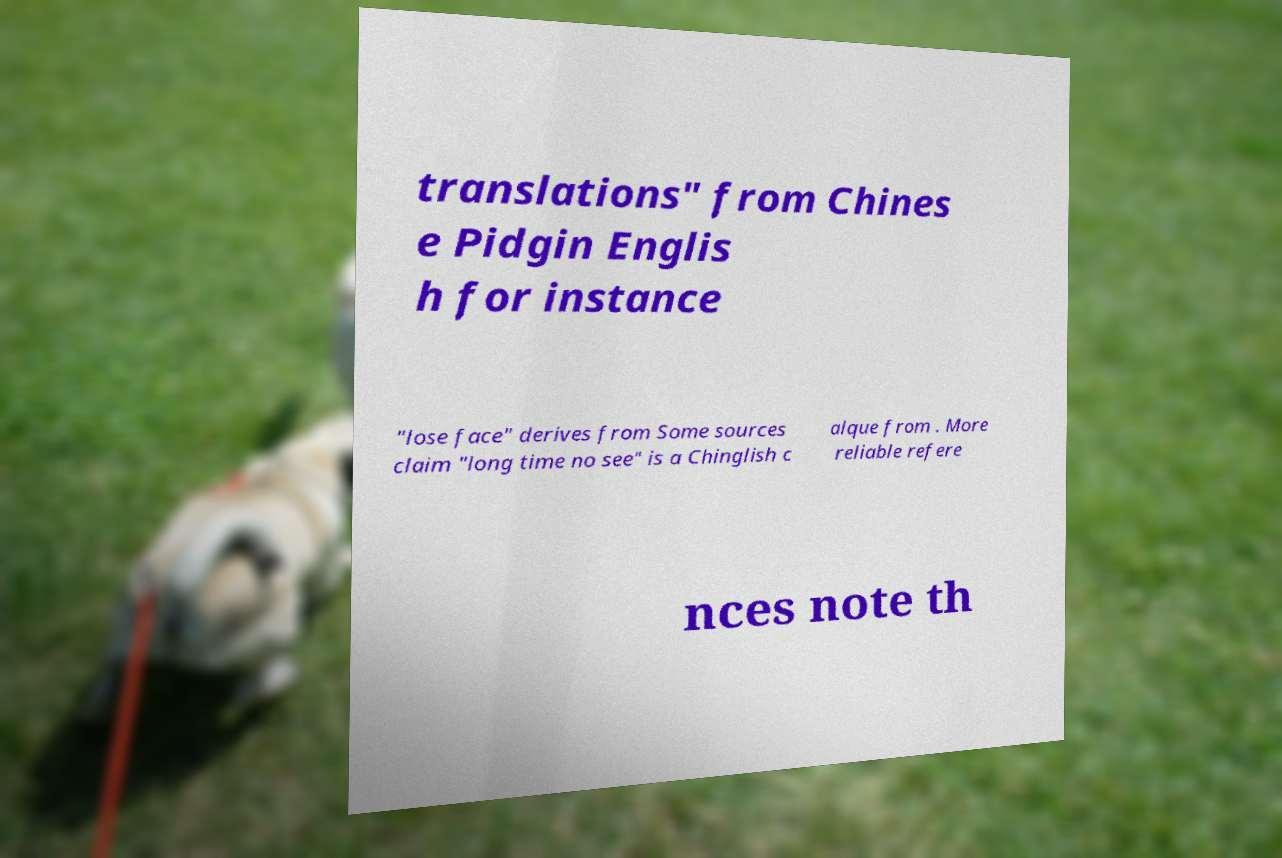There's text embedded in this image that I need extracted. Can you transcribe it verbatim? translations" from Chines e Pidgin Englis h for instance "lose face" derives from Some sources claim "long time no see" is a Chinglish c alque from . More reliable refere nces note th 